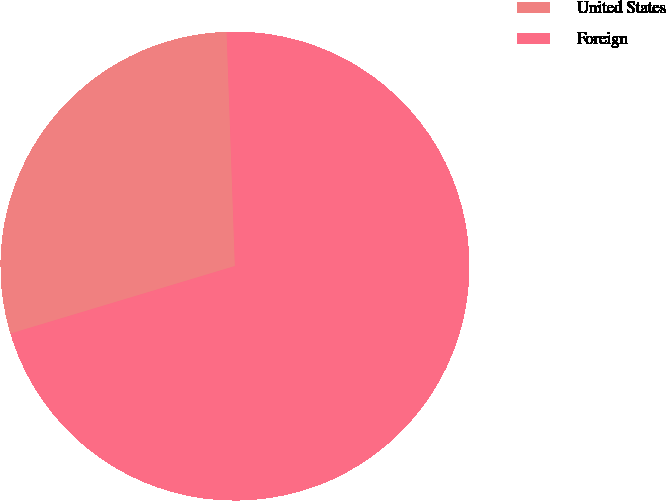Convert chart to OTSL. <chart><loc_0><loc_0><loc_500><loc_500><pie_chart><fcel>United States<fcel>Foreign<nl><fcel>29.09%<fcel>70.91%<nl></chart> 